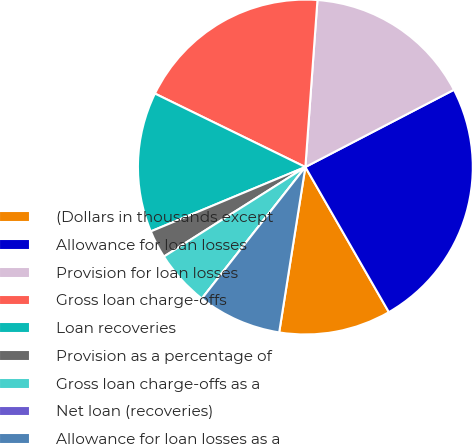Convert chart to OTSL. <chart><loc_0><loc_0><loc_500><loc_500><pie_chart><fcel>(Dollars in thousands except<fcel>Allowance for loan losses<fcel>Provision for loan losses<fcel>Gross loan charge-offs<fcel>Loan recoveries<fcel>Provision as a percentage of<fcel>Gross loan charge-offs as a<fcel>Net loan (recoveries)<fcel>Allowance for loan losses as a<nl><fcel>10.81%<fcel>24.32%<fcel>16.22%<fcel>18.92%<fcel>13.51%<fcel>2.7%<fcel>5.41%<fcel>0.0%<fcel>8.11%<nl></chart> 